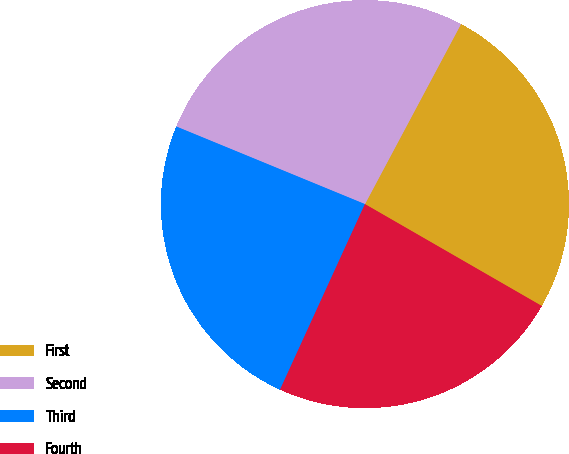<chart> <loc_0><loc_0><loc_500><loc_500><pie_chart><fcel>First<fcel>Second<fcel>Third<fcel>Fourth<nl><fcel>25.52%<fcel>26.59%<fcel>24.38%<fcel>23.51%<nl></chart> 